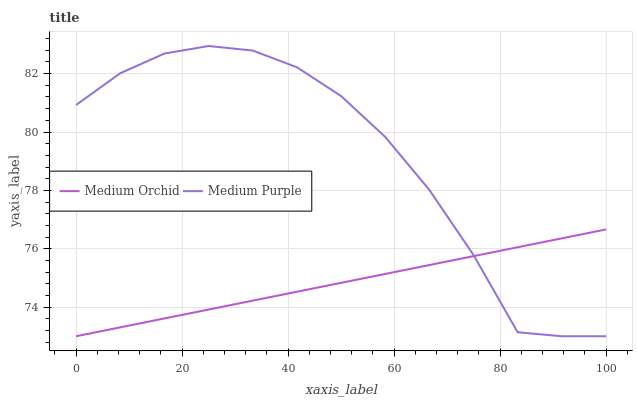Does Medium Orchid have the minimum area under the curve?
Answer yes or no. Yes. Does Medium Purple have the maximum area under the curve?
Answer yes or no. Yes. Does Medium Orchid have the maximum area under the curve?
Answer yes or no. No. Is Medium Orchid the smoothest?
Answer yes or no. Yes. Is Medium Purple the roughest?
Answer yes or no. Yes. Is Medium Orchid the roughest?
Answer yes or no. No. Does Medium Purple have the lowest value?
Answer yes or no. Yes. Does Medium Purple have the highest value?
Answer yes or no. Yes. Does Medium Orchid have the highest value?
Answer yes or no. No. Does Medium Purple intersect Medium Orchid?
Answer yes or no. Yes. Is Medium Purple less than Medium Orchid?
Answer yes or no. No. Is Medium Purple greater than Medium Orchid?
Answer yes or no. No. 